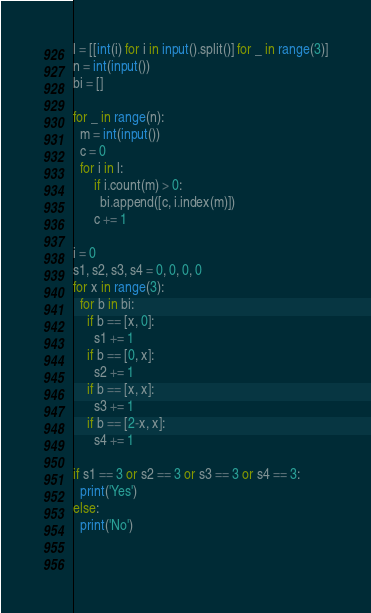Convert code to text. <code><loc_0><loc_0><loc_500><loc_500><_Python_>l = [[int(i) for i in input().split()] for _ in range(3)]
n = int(input())
bi = []

for _ in range(n):
  m = int(input())
  c = 0
  for i in l:
      if i.count(m) > 0:
        bi.append([c, i.index(m)])
      c += 1

i = 0
s1, s2, s3, s4 = 0, 0, 0, 0
for x in range(3):
  for b in bi:
    if b == [x, 0]:
      s1 += 1
    if b == [0, x]:
      s2 += 1
    if b == [x, x]:
      s3 += 1
    if b == [2-x, x]:
      s4 += 1

if s1 == 3 or s2 == 3 or s3 == 3 or s4 == 3:
  print('Yes')
else:
  print('No')
  
  </code> 